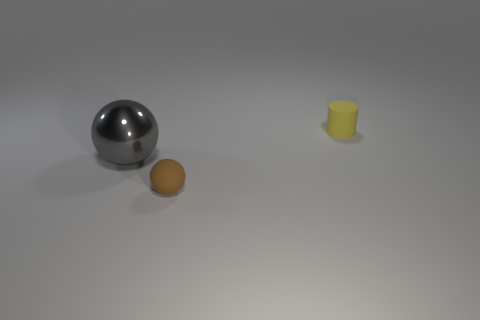Are there an equal number of gray balls behind the small yellow cylinder and small brown balls that are to the left of the large gray sphere?
Your answer should be compact. Yes. What material is the object that is right of the thing in front of the large object?
Ensure brevity in your answer.  Rubber. What number of objects are large matte spheres or objects that are on the right side of the gray shiny object?
Provide a short and direct response. 2. What is the size of the brown object that is made of the same material as the yellow thing?
Your response must be concise. Small. Is the number of small brown balls that are in front of the tiny yellow matte object greater than the number of big matte spheres?
Your answer should be very brief. Yes. There is a object that is on the left side of the matte cylinder and behind the small brown rubber object; what is its size?
Provide a short and direct response. Large. There is a brown thing that is the same shape as the large gray metallic thing; what is it made of?
Give a very brief answer. Rubber. Is the size of the rubber thing left of the yellow cylinder the same as the small cylinder?
Your answer should be compact. Yes. What is the color of the thing that is both left of the yellow matte cylinder and behind the small brown rubber object?
Your response must be concise. Gray. There is a tiny thing that is on the left side of the yellow rubber thing; what number of small matte cylinders are behind it?
Keep it short and to the point. 1. 